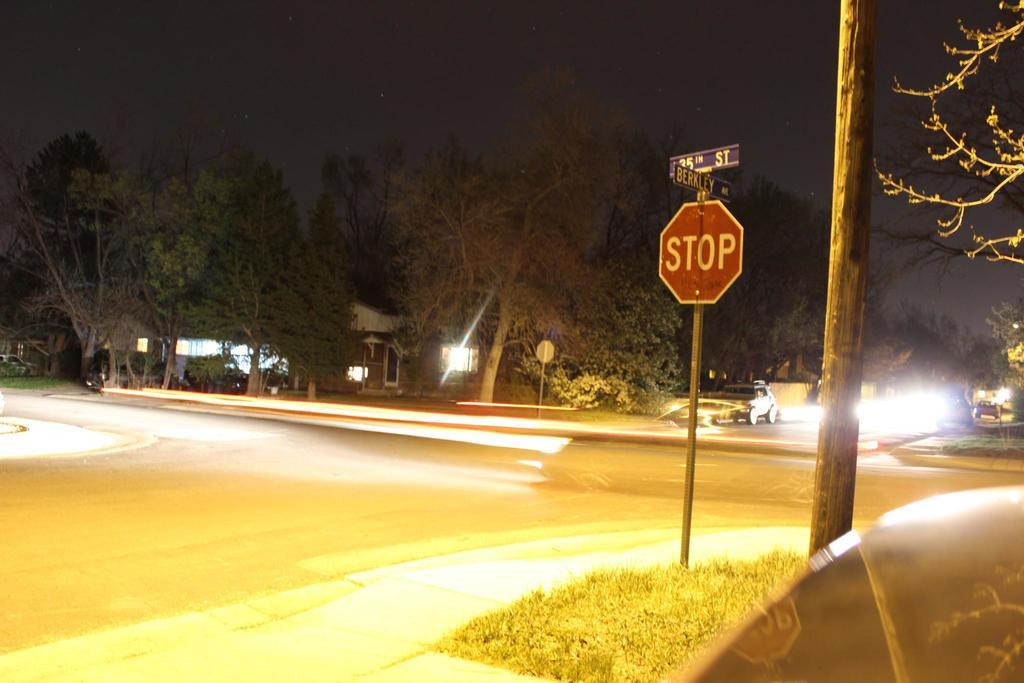What is the sign telling drivers to do?
Offer a very short reply. Stop. What street are they on?
Your answer should be compact. Berkley. 